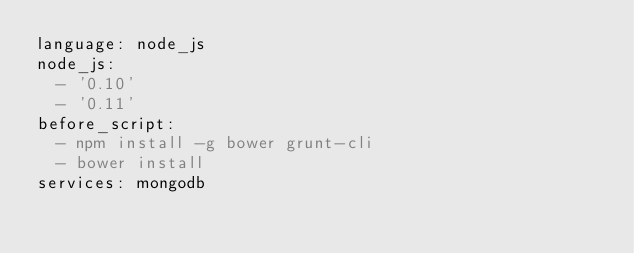<code> <loc_0><loc_0><loc_500><loc_500><_YAML_>language: node_js
node_js:
  - '0.10'
  - '0.11'
before_script:
  - npm install -g bower grunt-cli
  - bower install
services: mongodb</code> 